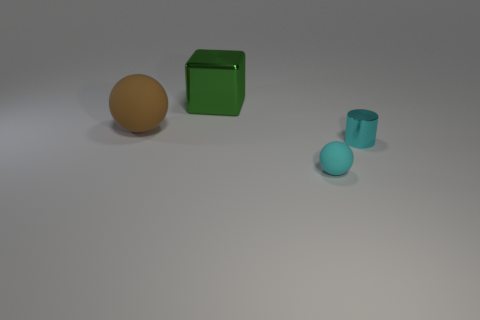What number of big objects are either red rubber things or cyan matte objects?
Offer a very short reply. 0. There is a thing that is on the left side of the tiny matte thing and in front of the green cube; what material is it?
Give a very brief answer. Rubber. Does the shiny thing that is behind the tiny shiny cylinder have the same shape as the object that is left of the cube?
Your answer should be compact. No. What is the shape of the small metal thing that is the same color as the small sphere?
Your answer should be compact. Cylinder. What number of objects are either tiny cyan objects that are left of the tiny cylinder or big green metal blocks?
Provide a succinct answer. 2. Is the size of the brown ball the same as the cyan rubber thing?
Make the answer very short. No. The ball behind the cyan matte ball is what color?
Provide a short and direct response. Brown. What is the size of the green thing that is the same material as the cylinder?
Provide a succinct answer. Large. There is a cyan matte sphere; does it have the same size as the matte object to the left of the metal block?
Your response must be concise. No. What material is the small object that is on the left side of the small cyan metallic thing?
Make the answer very short. Rubber. 